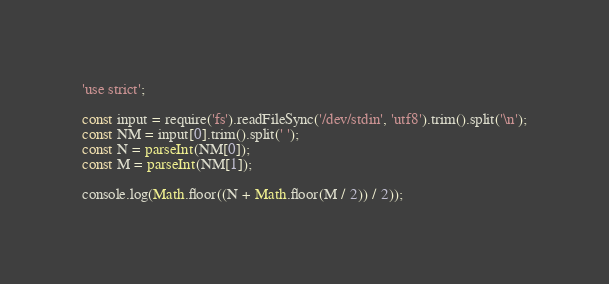Convert code to text. <code><loc_0><loc_0><loc_500><loc_500><_JavaScript_>'use strict';

const input = require('fs').readFileSync('/dev/stdin', 'utf8').trim().split('\n');
const NM = input[0].trim().split(' ');
const N = parseInt(NM[0]);
const M = parseInt(NM[1]);

console.log(Math.floor((N + Math.floor(M / 2)) / 2));</code> 